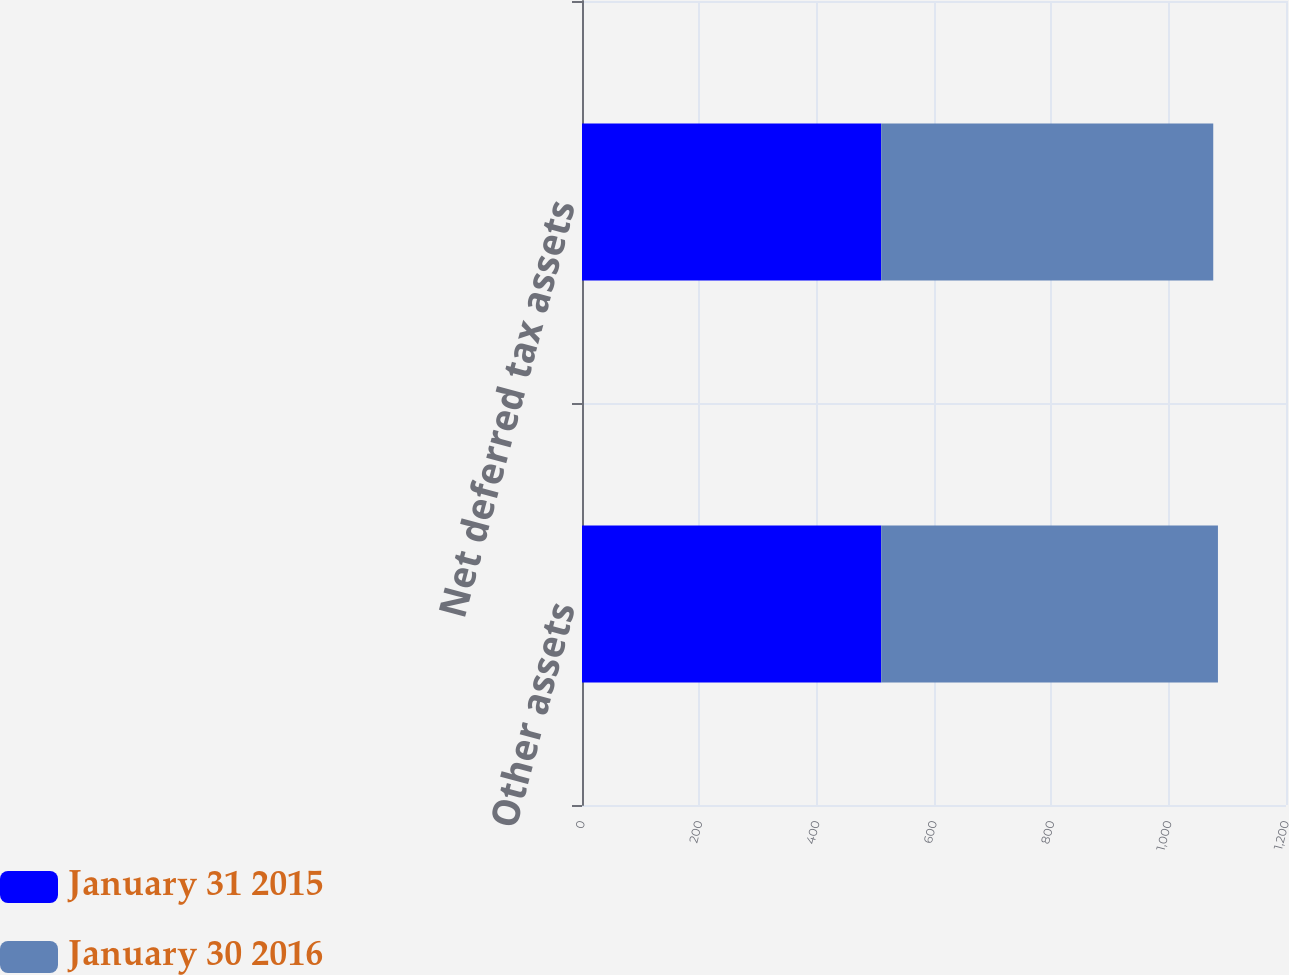Convert chart. <chart><loc_0><loc_0><loc_500><loc_500><stacked_bar_chart><ecel><fcel>Other assets<fcel>Net deferred tax assets<nl><fcel>January 31 2015<fcel>510<fcel>510<nl><fcel>January 30 2016<fcel>574<fcel>566<nl></chart> 